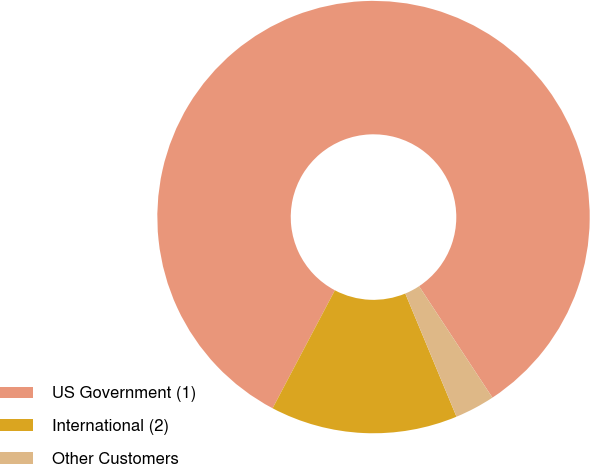<chart> <loc_0><loc_0><loc_500><loc_500><pie_chart><fcel>US Government (1)<fcel>International (2)<fcel>Other Customers<nl><fcel>83.0%<fcel>14.0%<fcel>3.0%<nl></chart> 